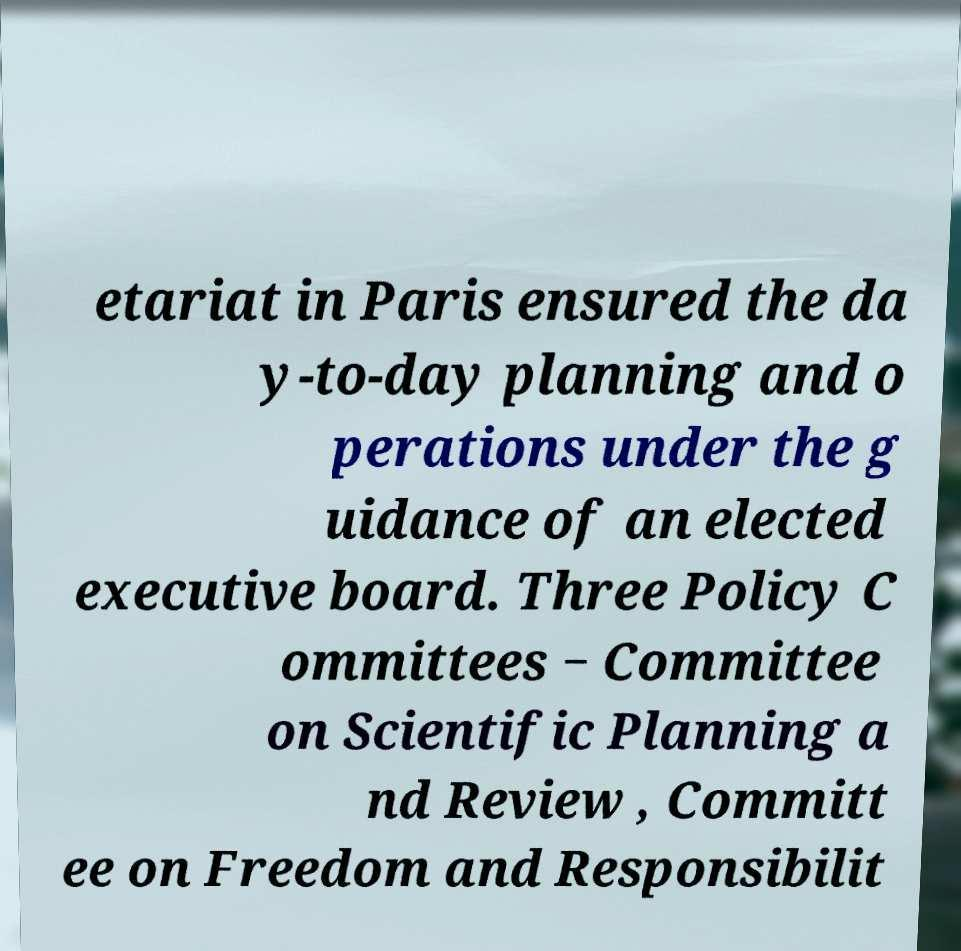There's text embedded in this image that I need extracted. Can you transcribe it verbatim? etariat in Paris ensured the da y-to-day planning and o perations under the g uidance of an elected executive board. Three Policy C ommittees − Committee on Scientific Planning a nd Review , Committ ee on Freedom and Responsibilit 